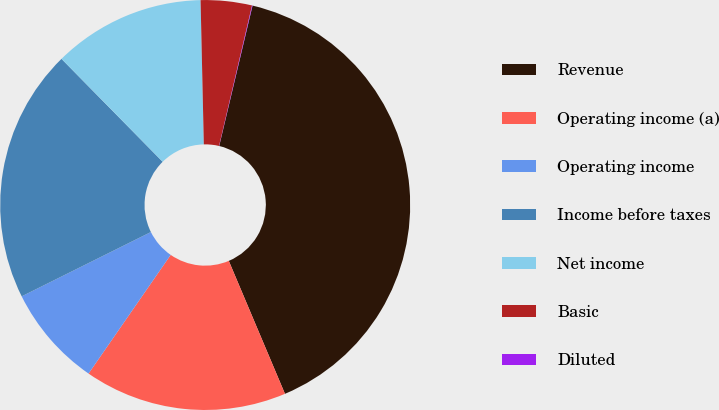Convert chart. <chart><loc_0><loc_0><loc_500><loc_500><pie_chart><fcel>Revenue<fcel>Operating income (a)<fcel>Operating income<fcel>Income before taxes<fcel>Net income<fcel>Basic<fcel>Diluted<nl><fcel>39.94%<fcel>16.0%<fcel>8.02%<fcel>19.99%<fcel>12.01%<fcel>4.03%<fcel>0.04%<nl></chart> 